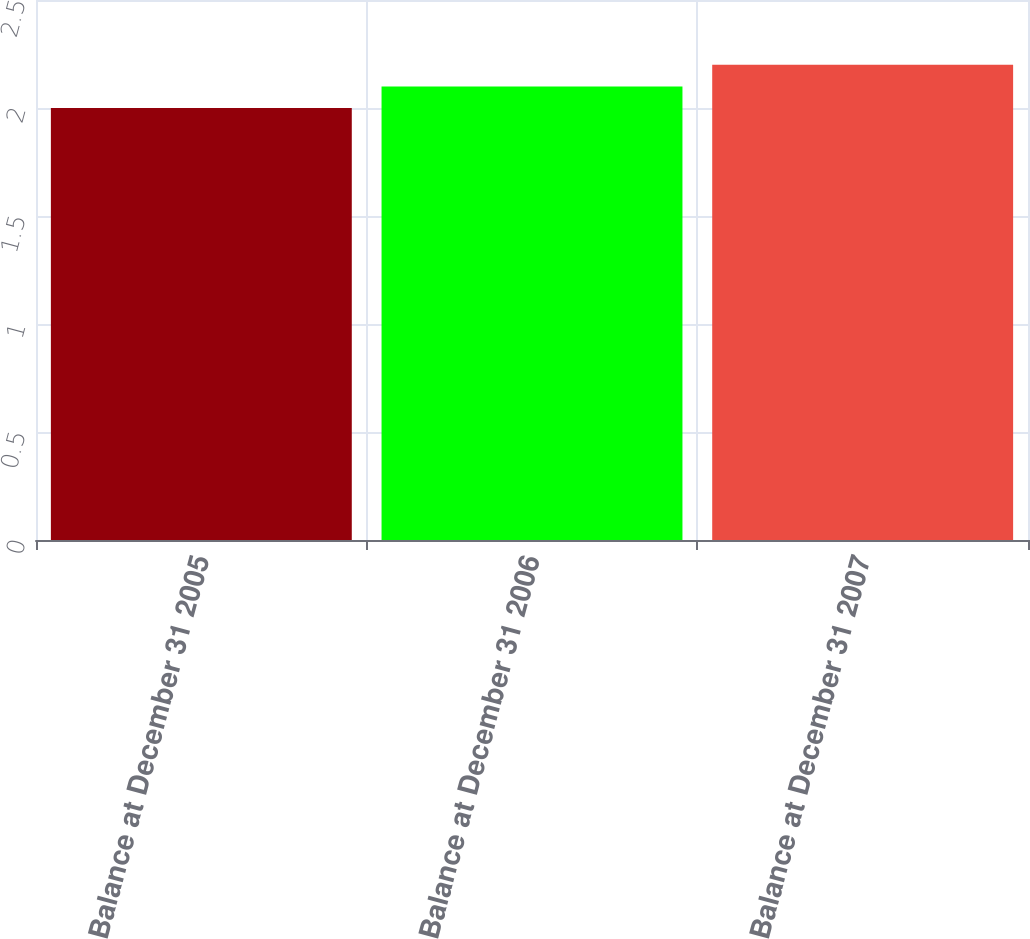Convert chart. <chart><loc_0><loc_0><loc_500><loc_500><bar_chart><fcel>Balance at December 31 2005<fcel>Balance at December 31 2006<fcel>Balance at December 31 2007<nl><fcel>2<fcel>2.1<fcel>2.2<nl></chart> 